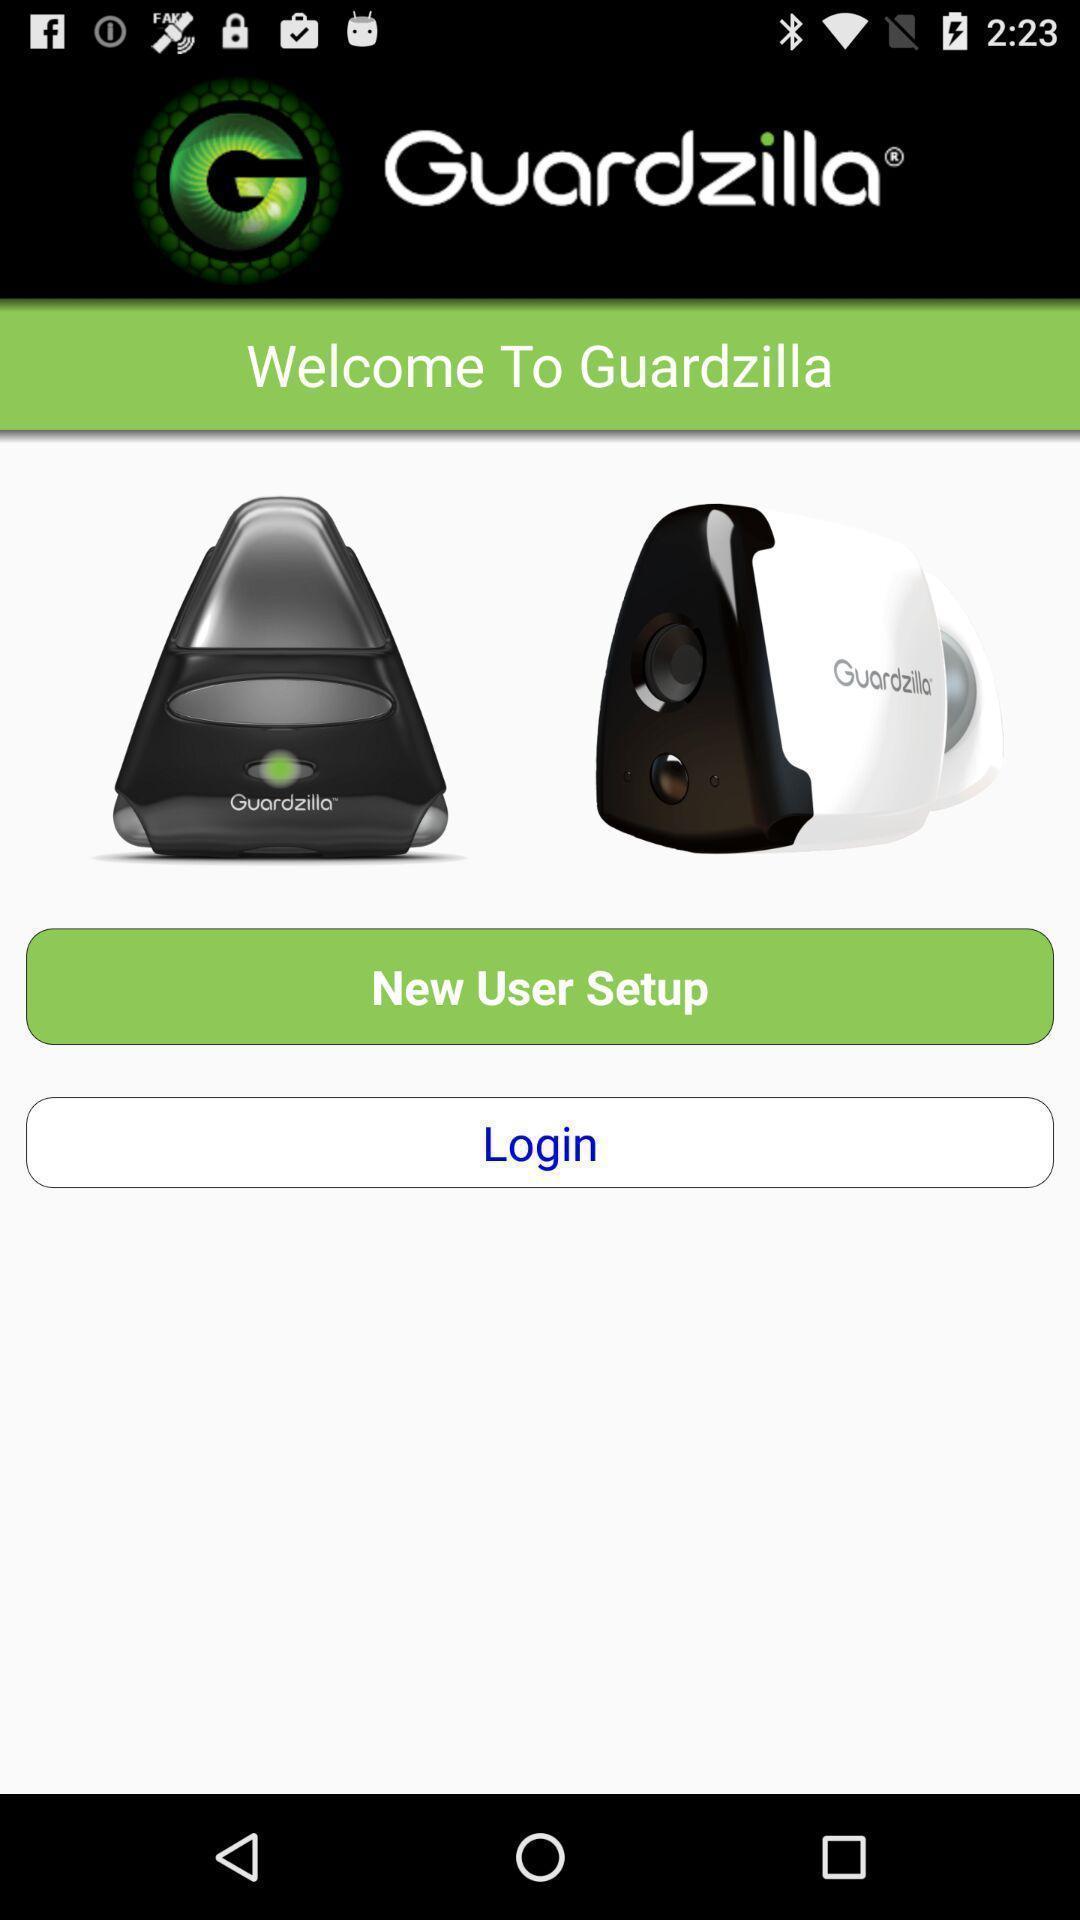Summarize the main components in this picture. Page asking to login. 